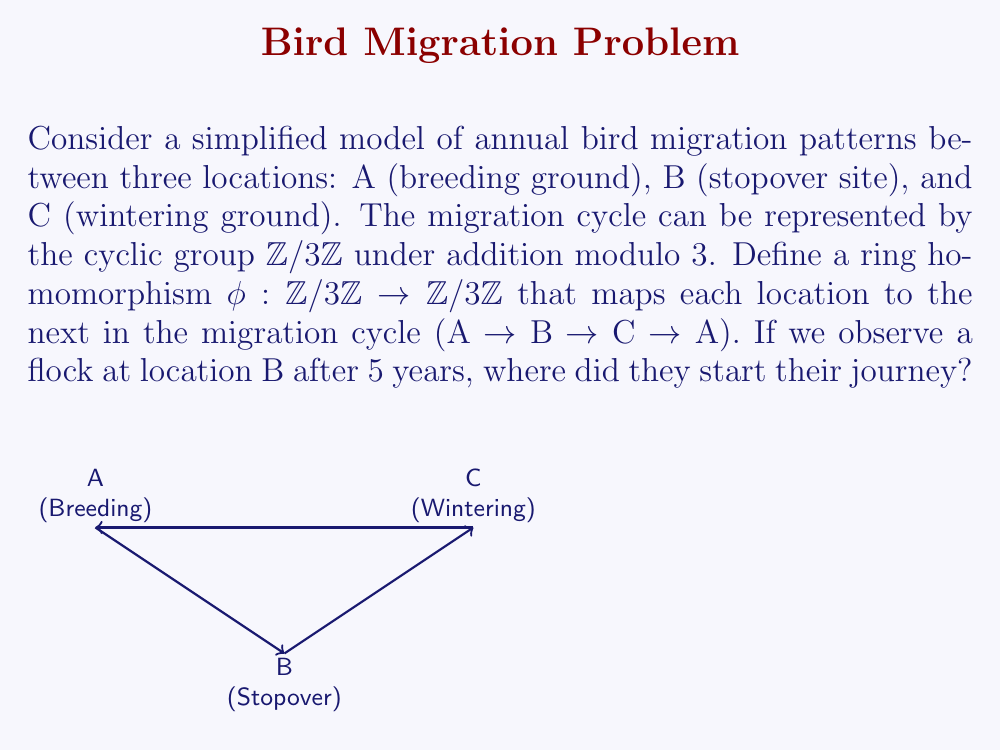Provide a solution to this math problem. Let's approach this step-by-step:

1) First, we need to understand the ring homomorphism $\phi$:
   $\phi(0) = 1$, $\phi(1) = 2$, $\phi(2) = 0$ (where 0 represents A, 1 represents B, and 2 represents C)

2) We can represent the migration over 5 years as applying $\phi$ five times:
   $\phi^5 = \phi \circ \phi \circ \phi \circ \phi \circ \phi$

3) Let's calculate $\phi^5(1)$ since we know the flock is at B (represented by 1) after 5 years:
   $\phi^5(1) = \phi(\phi(\phi(\phi(\phi(1)))))$
   $= \phi(\phi(\phi(\phi(2))))$
   $= \phi(\phi(\phi(0)))$
   $= \phi(\phi(1))$
   $= \phi(2)$
   $= 0$

4) So, $\phi^5(1) = 0$, which means after 5 years, starting from B, the flock ends up at A.

5) To find where they started, we need to find $x$ such that $\phi^5(x) = 1$ (since they end up at B after 5 years).

6) We can work backwards:
   $\phi^5(2) = \phi^4(0) = \phi^3(1) = \phi^2(2) = \phi(0) = 1$

Therefore, the flock must have started at location C (represented by 2).
Answer: C (Wintering ground) 